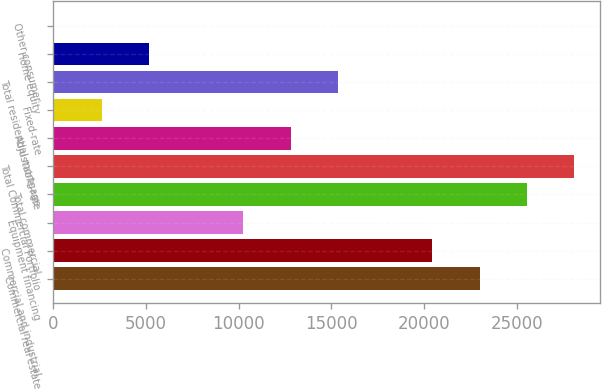Convert chart to OTSL. <chart><loc_0><loc_0><loc_500><loc_500><bar_chart><fcel>Commercial real estate<fcel>Commercial and industrial<fcel>Equipment financing<fcel>Total commercial<fcel>Total Commercial Portfolio<fcel>Adjustable-rate<fcel>Fixed-rate<fcel>Total residential mortgage<fcel>Home equity<fcel>Other consumer<nl><fcel>22992.6<fcel>20444.1<fcel>10250.2<fcel>25541.1<fcel>28089.6<fcel>12798.7<fcel>2604.78<fcel>15347.2<fcel>5153.26<fcel>56.3<nl></chart> 